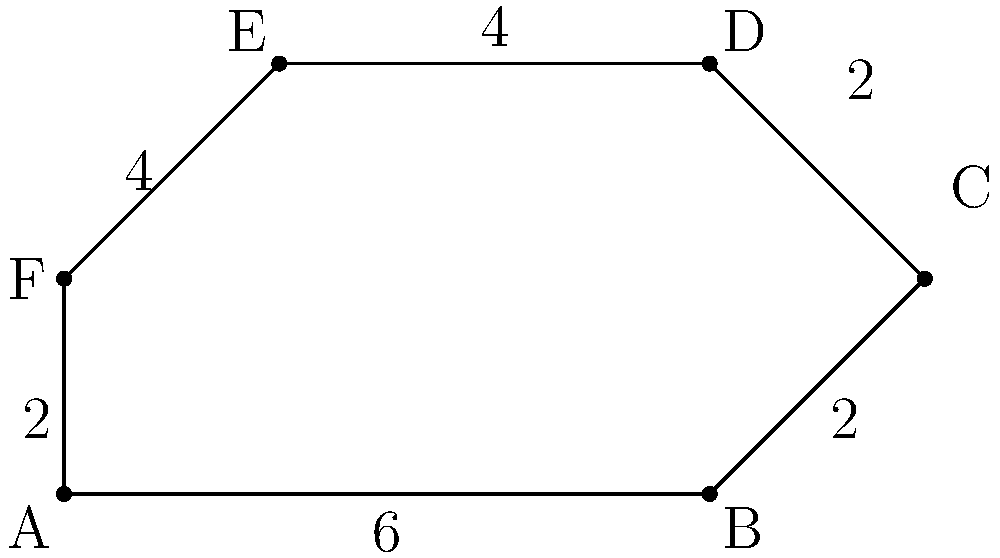At the Horse Trough Fountain, you overhear a discussion about a new dog park being planned in Portland. The park's shape is an irregular hexagon, as shown in the diagram. If the measurements are in yards, what is the total area of the dog park in square yards? To find the area of this irregular hexagon, we can divide it into simpler shapes:

1. Divide the hexagon into a rectangle and two triangles.

2. Calculate the area of the rectangle:
   Length = 6 yards, Width = 4 yards
   Area of rectangle = $6 \times 4 = 24$ sq yards

3. Calculate the area of the right triangle on the right:
   Base = 2 yards, Height = 2 yards
   Area of right triangle = $\frac{1}{2} \times 2 \times 2 = 2$ sq yards

4. Calculate the area of the right triangle on the left:
   Base = 2 yards, Height = 2 yards
   Area of left triangle = $\frac{1}{2} \times 2 \times 2 = 2$ sq yards

5. Sum up all areas:
   Total Area = Rectangle + Right Triangle + Left Triangle
               = $24 + 2 + 2 = 28$ sq yards

Therefore, the total area of the dog park is 28 square yards.
Answer: 28 sq yards 